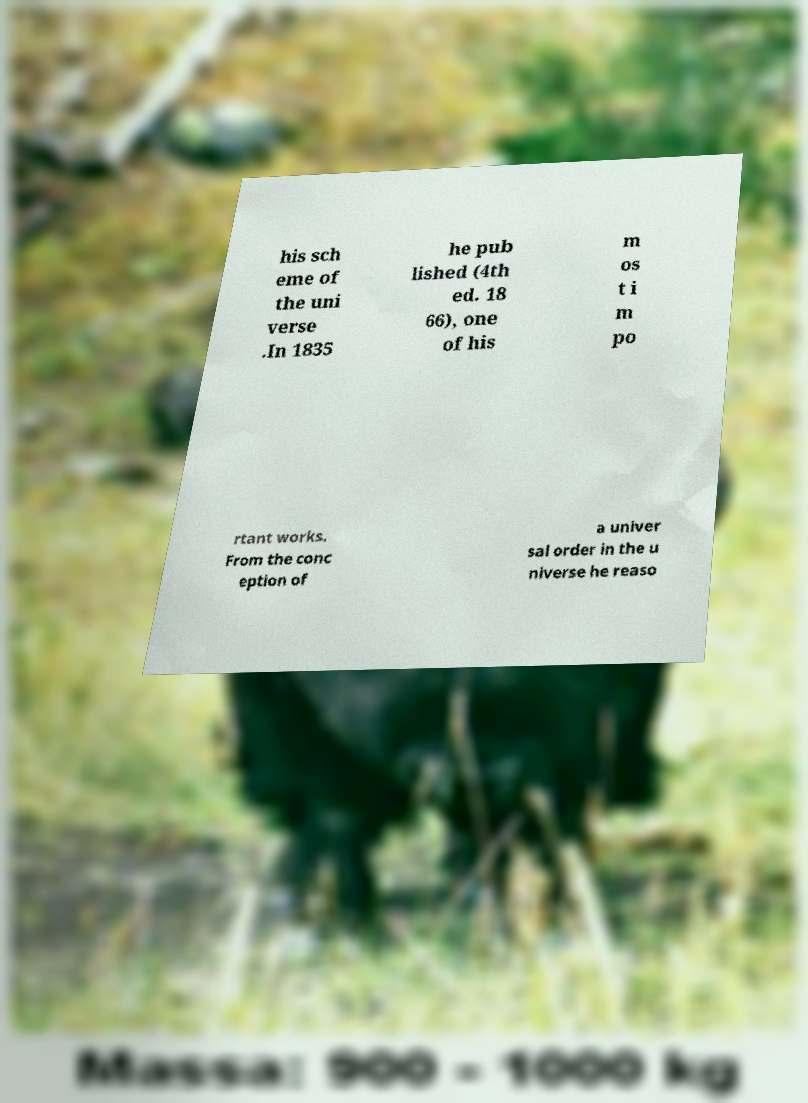For documentation purposes, I need the text within this image transcribed. Could you provide that? his sch eme of the uni verse .In 1835 he pub lished (4th ed. 18 66), one of his m os t i m po rtant works. From the conc eption of a univer sal order in the u niverse he reaso 